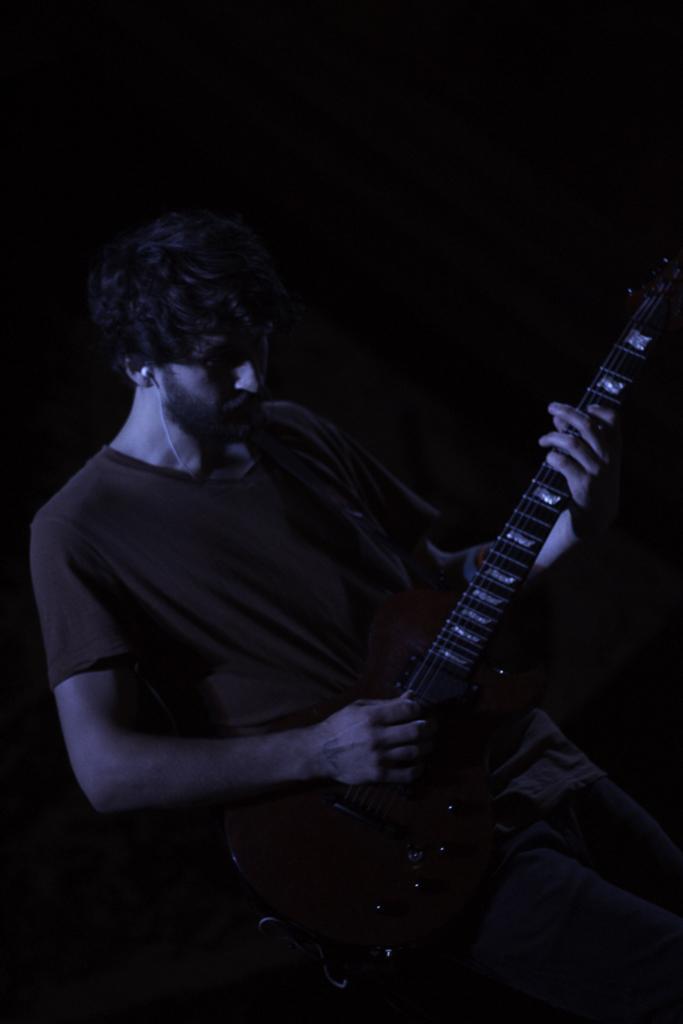In one or two sentences, can you explain what this image depicts? In this picture there is a man playing a guitar. He is wearing t shirt and jeans. There is a ear phone in one ear. 